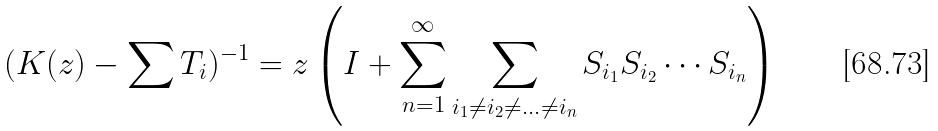Convert formula to latex. <formula><loc_0><loc_0><loc_500><loc_500>( K ( z ) - \sum T _ { i } ) ^ { - 1 } = z \left ( I + \sum _ { n = 1 } ^ { \infty } \sum _ { i _ { 1 } \ne i _ { 2 } \ne \dots \ne i _ { n } } S _ { i _ { 1 } } S _ { i _ { 2 } } \cdots S _ { i _ { n } } \right )</formula> 